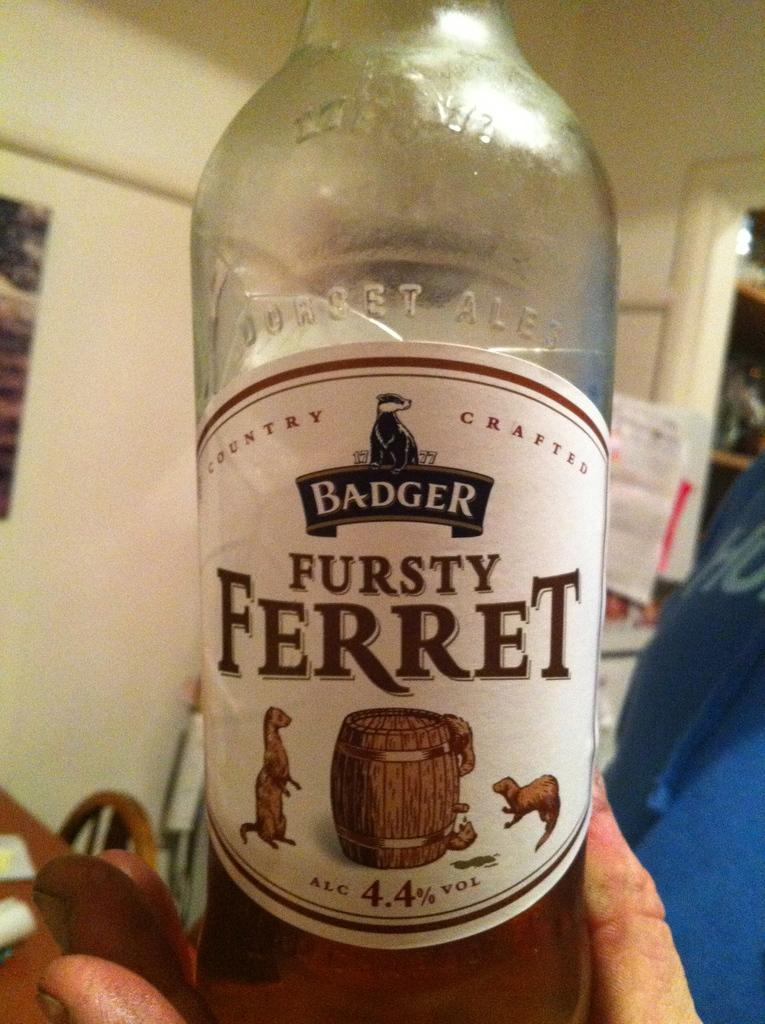What object is being held by a person in the image? There is a bottle in the image, and it is being held by a person. What is written on the bottle? The word "ferret" is written on the bottle. What game is being played in the image? There is no game being played in the image; it only shows a person holding a bottle with the word "ferret" written on it. 